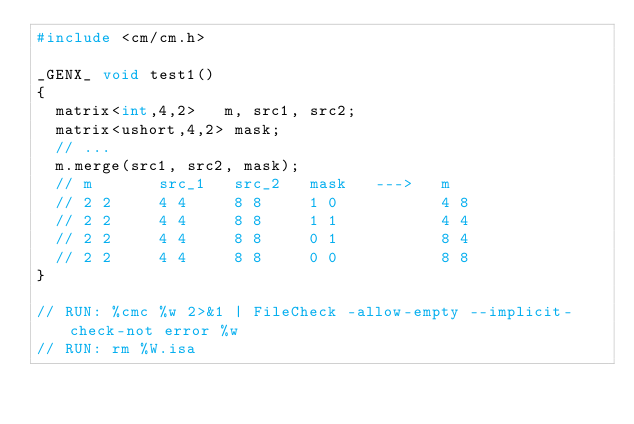Convert code to text. <code><loc_0><loc_0><loc_500><loc_500><_C++_>#include <cm/cm.h>

_GENX_ void test1()
{
  matrix<int,4,2>   m, src1, src2;
  matrix<ushort,4,2> mask;
  // ...
  m.merge(src1, src2, mask);
  // m       src_1   src_2   mask   --->   m
  // 2 2     4 4     8 8     1 0           4 8
  // 2 2     4 4     8 8     1 1           4 4
  // 2 2     4 4     8 8     0 1           8 4
  // 2 2     4 4     8 8     0 0           8 8
}

// RUN: %cmc %w 2>&1 | FileCheck -allow-empty --implicit-check-not error %w
// RUN: rm %W.isa
</code> 